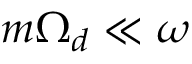<formula> <loc_0><loc_0><loc_500><loc_500>m \Omega _ { d } \ll \omega</formula> 